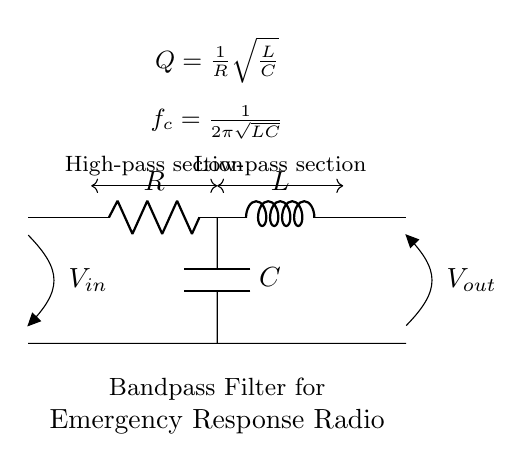What type of components are present in this circuit? The circuit contains a resistor, an inductor, and a capacitor, which are the key components indicated in the circuit diagram.
Answer: Resistor, Inductor, Capacitor What is the configuration of the circuit? This is a bandpass filter configuration, as suggested by the arrangement of the components with a resistor, inductor, and capacitor placed to allow certain frequencies to pass while blocking others.
Answer: Bandpass filter What does the symbol "Vout" represent in this circuit? The symbol "Vout" represents the output voltage of the circuit, which is the voltage measured across the output terminals after the filtering action takes place.
Answer: Output voltage What does "Q" signify in this diagram? "Q" in this context represents the quality factor of the circuit, which indicates how underdamped the circuit is and its ability to select a narrow band of frequencies, related to the components' values.
Answer: Quality factor How is the cutoff frequency "fc" calculated? The cutoff frequency "fc" is calculated using the formula provided in the diagram, which is derived from the values of the inductor and capacitor in the circuit, expressed as fc equals one divided by two pi times the square root of the product of L and C.
Answer: 1/(2π√(LC)) What is the function of the resistor in this bandpass filter? The resistor serves to dampen the oscillations in the filter circuit, controlling the bandwidth and quality factor to determine how sharp or flat the filter response is around the cutoff frequency.
Answer: Damping oscillations In which situation would this bandpass filter be particularly useful? This filter would be particularly useful in emergency response systems for radio communication, where specific frequency bands need to be amplified while rejecting noise from other frequencies to ensure clear communication.
Answer: Emergency communication 